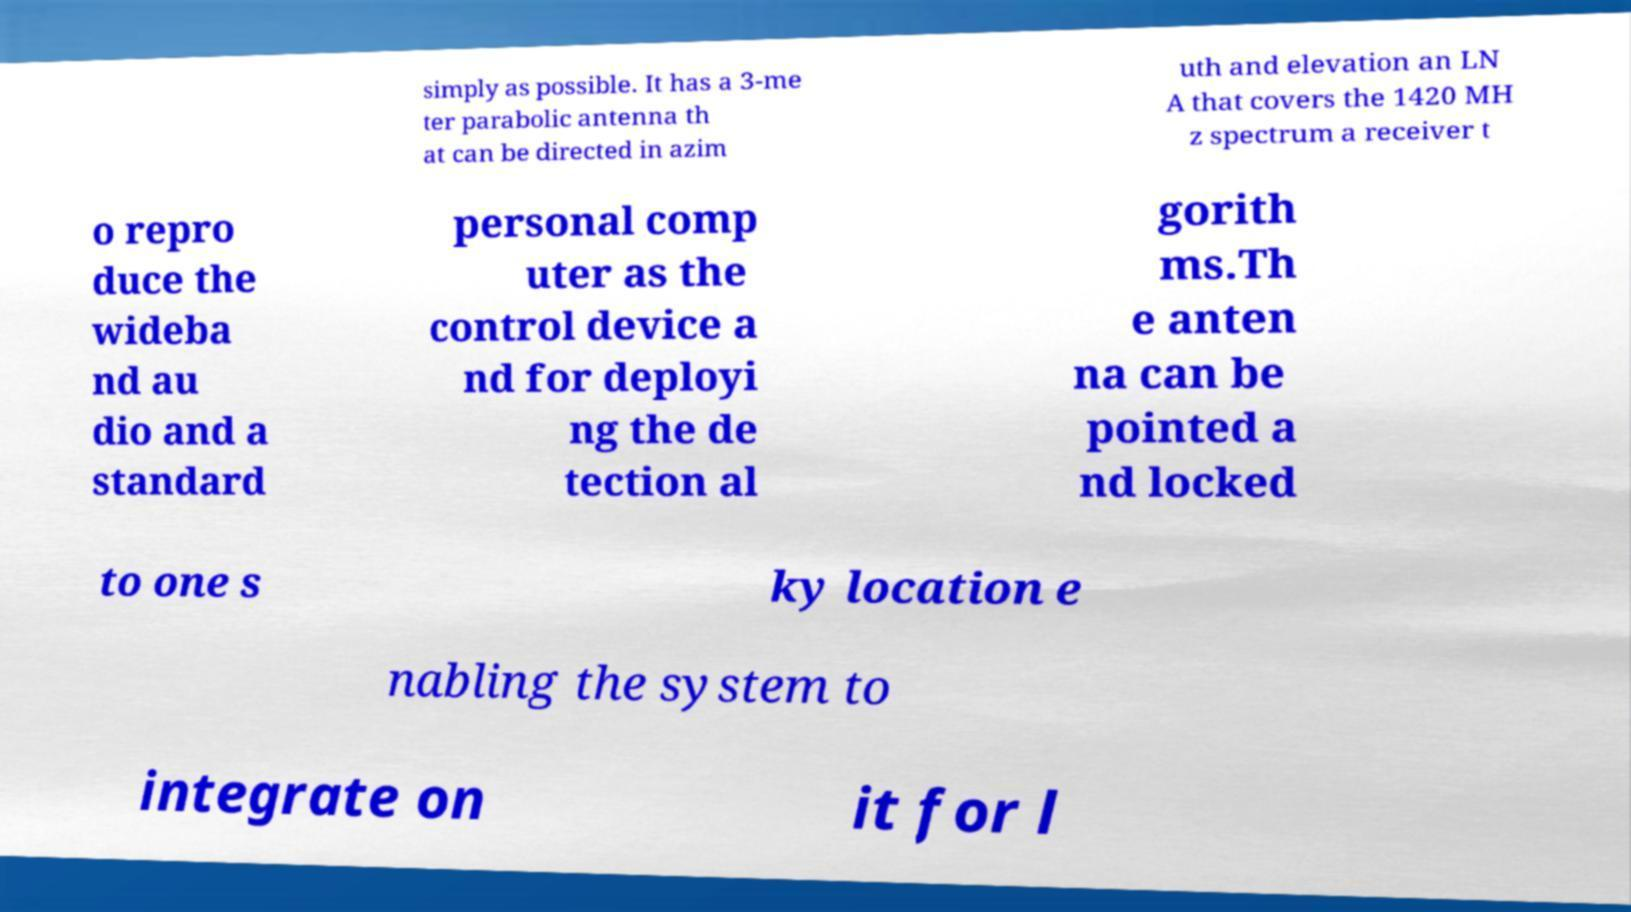What messages or text are displayed in this image? I need them in a readable, typed format. simply as possible. It has a 3-me ter parabolic antenna th at can be directed in azim uth and elevation an LN A that covers the 1420 MH z spectrum a receiver t o repro duce the wideba nd au dio and a standard personal comp uter as the control device a nd for deployi ng the de tection al gorith ms.Th e anten na can be pointed a nd locked to one s ky location e nabling the system to integrate on it for l 